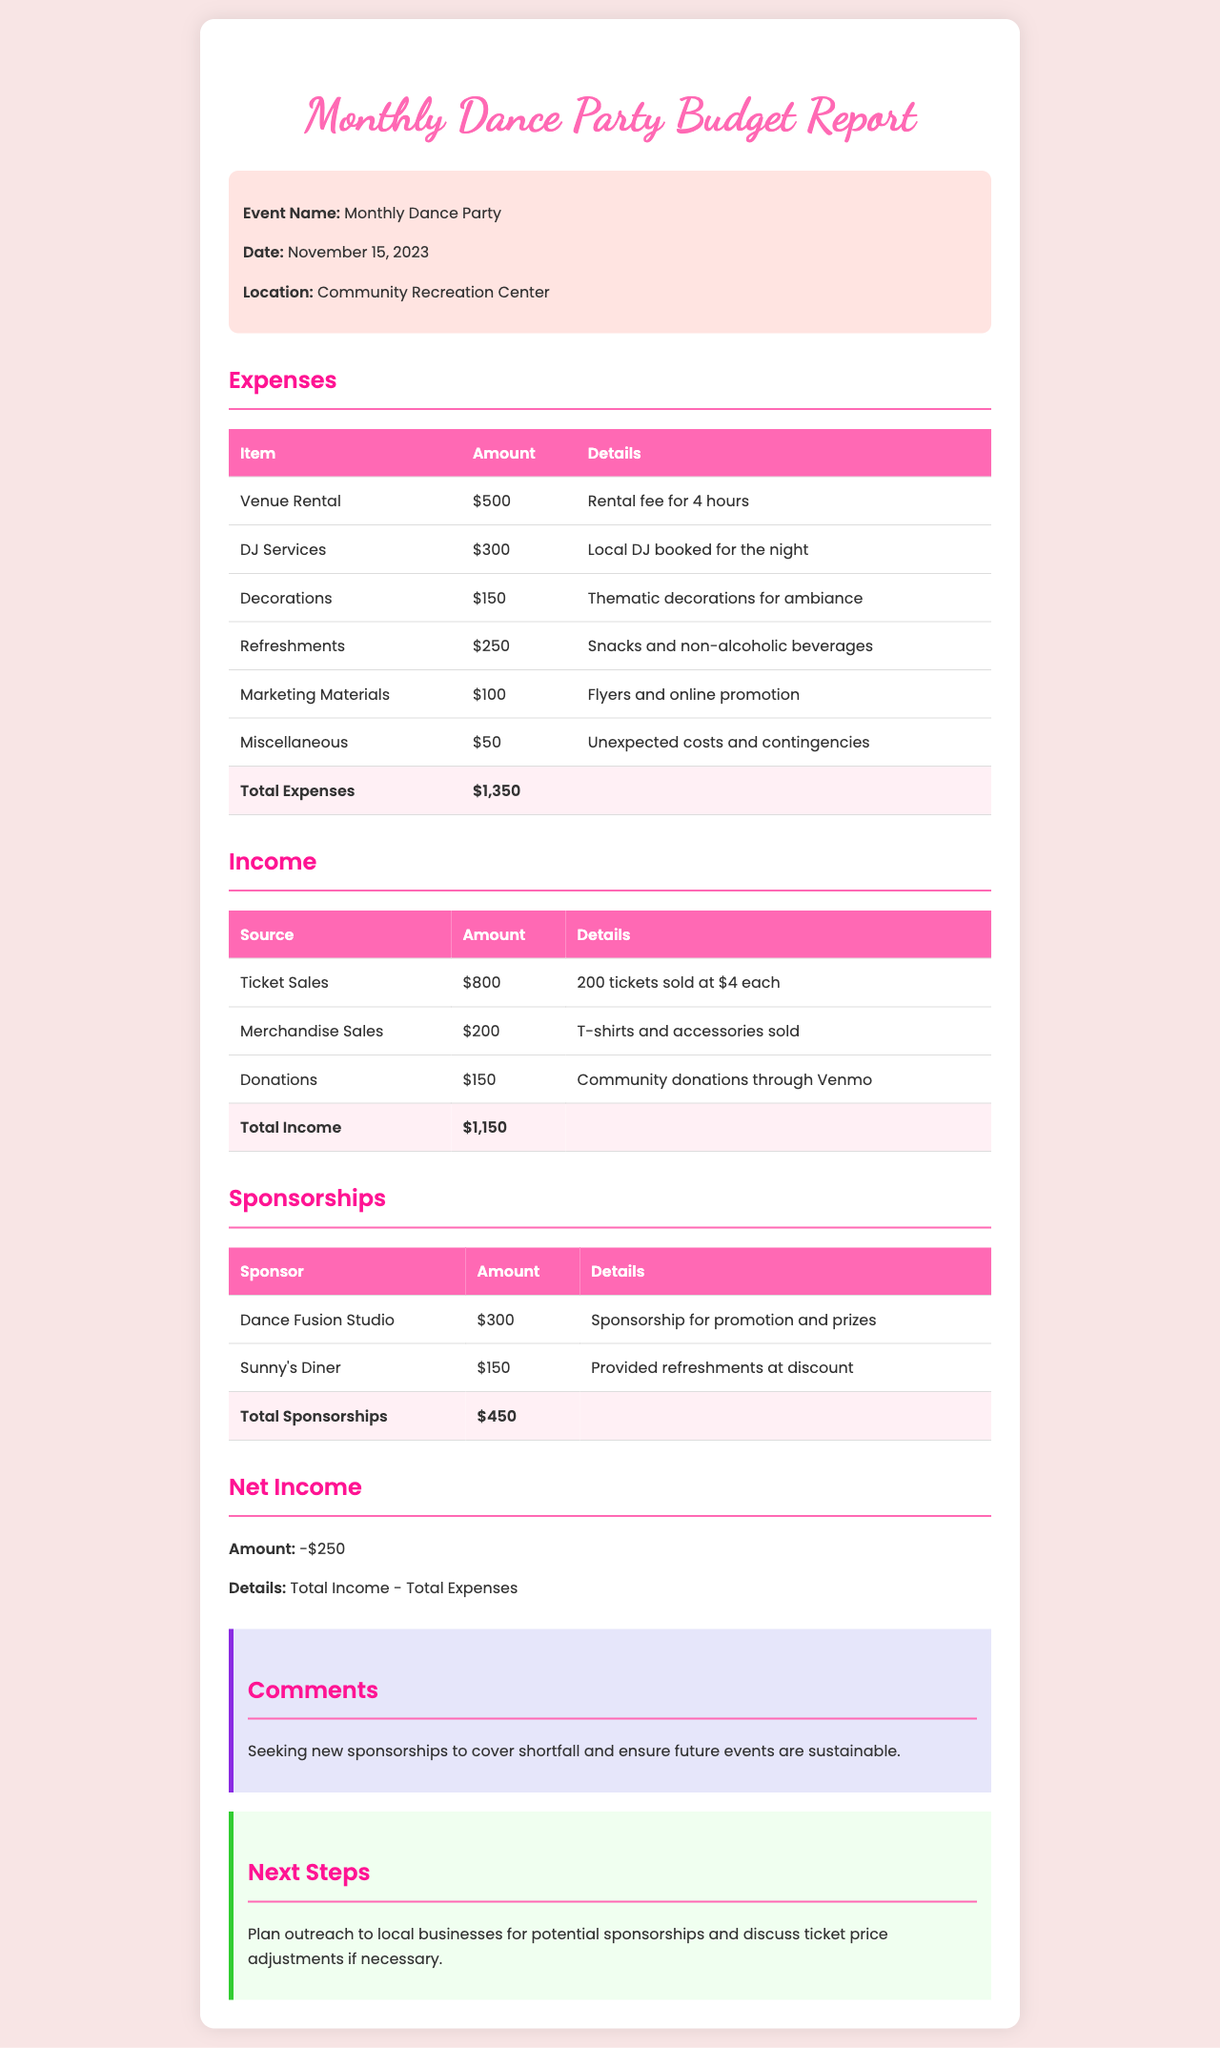What is the date of the dance party? The date of the dance party is mentioned in the 'Event Name' section of the document.
Answer: November 15, 2023 What is the total amount allocated for DJ services? The cost for DJ services is found in the 'Expenses' table under 'DJ Services'.
Answer: $300 What is the total income from ticket sales? The total from ticket sales is detailed in the 'Income' table under 'Ticket Sales'.
Answer: $800 What is the total amount of expenses? The total expenses are summarized in the 'Expenses' section at the bottom of the table.
Answer: $1,350 What is the total amount of sponsorships received? The total sponsorships are displayed in the 'Sponsorships' section at the bottom of the table.
Answer: $450 What is the net income? The net income is calculated as Total Income minus Total Expenses, provided in the 'Net Income' section of the document.
Answer: -$250 What is the primary reason for the negative net income? The reason for the negative net income is outlined in the 'Net Income' section.
Answer: Total Income - Total Expenses What are the next steps planned for the dance party? The next steps for the event are described in the 'Next Steps' section.
Answer: Outreach for sponsorships How many tickets were sold? The total number of tickets sold is mentioned in the 'Income' table under 'Ticket Sales'.
Answer: 200 